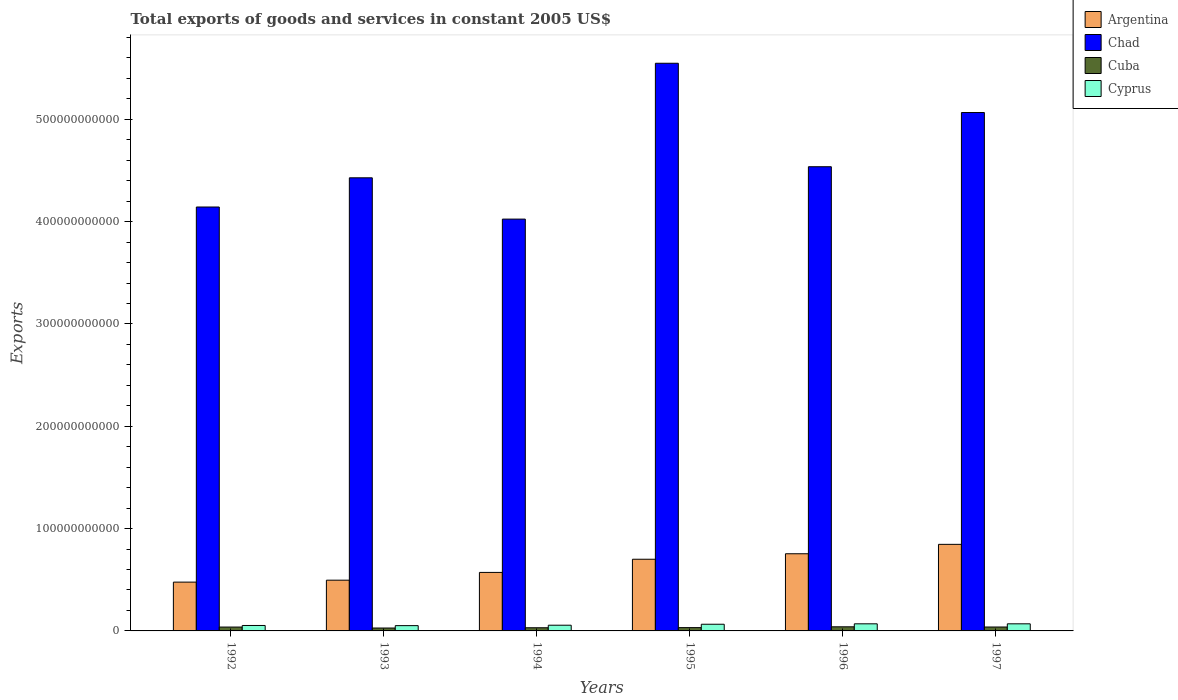How many groups of bars are there?
Provide a succinct answer. 6. Are the number of bars on each tick of the X-axis equal?
Your answer should be compact. Yes. How many bars are there on the 4th tick from the left?
Provide a succinct answer. 4. What is the label of the 4th group of bars from the left?
Offer a very short reply. 1995. What is the total exports of goods and services in Cyprus in 1992?
Provide a short and direct response. 5.31e+09. Across all years, what is the maximum total exports of goods and services in Argentina?
Provide a short and direct response. 8.46e+1. Across all years, what is the minimum total exports of goods and services in Argentina?
Provide a short and direct response. 4.77e+1. In which year was the total exports of goods and services in Chad minimum?
Offer a terse response. 1994. What is the total total exports of goods and services in Cuba in the graph?
Your answer should be compact. 2.08e+1. What is the difference between the total exports of goods and services in Argentina in 1993 and that in 1997?
Your response must be concise. -3.50e+1. What is the difference between the total exports of goods and services in Cuba in 1996 and the total exports of goods and services in Argentina in 1994?
Your answer should be compact. -5.32e+1. What is the average total exports of goods and services in Cuba per year?
Your answer should be compact. 3.46e+09. In the year 1994, what is the difference between the total exports of goods and services in Cyprus and total exports of goods and services in Argentina?
Keep it short and to the point. -5.16e+1. In how many years, is the total exports of goods and services in Cyprus greater than 40000000000 US$?
Provide a succinct answer. 0. What is the ratio of the total exports of goods and services in Chad in 1993 to that in 1996?
Offer a terse response. 0.98. Is the total exports of goods and services in Argentina in 1992 less than that in 1995?
Ensure brevity in your answer.  Yes. What is the difference between the highest and the second highest total exports of goods and services in Argentina?
Keep it short and to the point. 9.18e+09. What is the difference between the highest and the lowest total exports of goods and services in Argentina?
Offer a very short reply. 3.69e+1. In how many years, is the total exports of goods and services in Chad greater than the average total exports of goods and services in Chad taken over all years?
Keep it short and to the point. 2. Is the sum of the total exports of goods and services in Cuba in 1992 and 1993 greater than the maximum total exports of goods and services in Chad across all years?
Your answer should be very brief. No. What does the 2nd bar from the left in 1993 represents?
Ensure brevity in your answer.  Chad. What does the 1st bar from the right in 1995 represents?
Give a very brief answer. Cyprus. How many bars are there?
Your response must be concise. 24. Are all the bars in the graph horizontal?
Offer a very short reply. No. How many years are there in the graph?
Offer a terse response. 6. What is the difference between two consecutive major ticks on the Y-axis?
Offer a terse response. 1.00e+11. Does the graph contain grids?
Your response must be concise. No. Where does the legend appear in the graph?
Your answer should be compact. Top right. What is the title of the graph?
Ensure brevity in your answer.  Total exports of goods and services in constant 2005 US$. Does "Grenada" appear as one of the legend labels in the graph?
Provide a succinct answer. No. What is the label or title of the Y-axis?
Make the answer very short. Exports. What is the Exports of Argentina in 1992?
Offer a terse response. 4.77e+1. What is the Exports of Chad in 1992?
Keep it short and to the point. 4.14e+11. What is the Exports of Cuba in 1992?
Offer a terse response. 3.77e+09. What is the Exports of Cyprus in 1992?
Make the answer very short. 5.31e+09. What is the Exports of Argentina in 1993?
Your response must be concise. 4.96e+1. What is the Exports of Chad in 1993?
Make the answer very short. 4.43e+11. What is the Exports in Cuba in 1993?
Your answer should be very brief. 2.83e+09. What is the Exports of Cyprus in 1993?
Keep it short and to the point. 5.16e+09. What is the Exports of Argentina in 1994?
Give a very brief answer. 5.72e+1. What is the Exports in Chad in 1994?
Your answer should be very brief. 4.03e+11. What is the Exports of Cuba in 1994?
Give a very brief answer. 3.09e+09. What is the Exports of Cyprus in 1994?
Offer a very short reply. 5.59e+09. What is the Exports of Argentina in 1995?
Give a very brief answer. 7.01e+1. What is the Exports of Chad in 1995?
Ensure brevity in your answer.  5.55e+11. What is the Exports of Cuba in 1995?
Your answer should be compact. 3.23e+09. What is the Exports of Cyprus in 1995?
Ensure brevity in your answer.  6.53e+09. What is the Exports of Argentina in 1996?
Provide a succinct answer. 7.54e+1. What is the Exports in Chad in 1996?
Make the answer very short. 4.54e+11. What is the Exports of Cuba in 1996?
Your answer should be compact. 4.02e+09. What is the Exports in Cyprus in 1996?
Keep it short and to the point. 6.93e+09. What is the Exports in Argentina in 1997?
Your answer should be compact. 8.46e+1. What is the Exports in Chad in 1997?
Offer a terse response. 5.07e+11. What is the Exports of Cuba in 1997?
Keep it short and to the point. 3.82e+09. What is the Exports of Cyprus in 1997?
Make the answer very short. 6.94e+09. Across all years, what is the maximum Exports of Argentina?
Provide a short and direct response. 8.46e+1. Across all years, what is the maximum Exports in Chad?
Your response must be concise. 5.55e+11. Across all years, what is the maximum Exports in Cuba?
Ensure brevity in your answer.  4.02e+09. Across all years, what is the maximum Exports of Cyprus?
Give a very brief answer. 6.94e+09. Across all years, what is the minimum Exports of Argentina?
Offer a terse response. 4.77e+1. Across all years, what is the minimum Exports in Chad?
Make the answer very short. 4.03e+11. Across all years, what is the minimum Exports of Cuba?
Ensure brevity in your answer.  2.83e+09. Across all years, what is the minimum Exports in Cyprus?
Provide a succinct answer. 5.16e+09. What is the total Exports of Argentina in the graph?
Offer a very short reply. 3.85e+11. What is the total Exports in Chad in the graph?
Your answer should be very brief. 2.77e+12. What is the total Exports in Cuba in the graph?
Your response must be concise. 2.08e+1. What is the total Exports of Cyprus in the graph?
Your answer should be compact. 3.65e+1. What is the difference between the Exports of Argentina in 1992 and that in 1993?
Offer a terse response. -1.90e+09. What is the difference between the Exports in Chad in 1992 and that in 1993?
Your answer should be compact. -2.85e+1. What is the difference between the Exports in Cuba in 1992 and that in 1993?
Provide a succinct answer. 9.41e+08. What is the difference between the Exports in Cyprus in 1992 and that in 1993?
Make the answer very short. 1.51e+08. What is the difference between the Exports in Argentina in 1992 and that in 1994?
Provide a succinct answer. -9.49e+09. What is the difference between the Exports of Chad in 1992 and that in 1994?
Offer a terse response. 1.18e+1. What is the difference between the Exports of Cuba in 1992 and that in 1994?
Offer a terse response. 6.82e+08. What is the difference between the Exports of Cyprus in 1992 and that in 1994?
Your answer should be very brief. -2.72e+08. What is the difference between the Exports of Argentina in 1992 and that in 1995?
Ensure brevity in your answer.  -2.24e+1. What is the difference between the Exports in Chad in 1992 and that in 1995?
Ensure brevity in your answer.  -1.41e+11. What is the difference between the Exports in Cuba in 1992 and that in 1995?
Give a very brief answer. 5.48e+08. What is the difference between the Exports in Cyprus in 1992 and that in 1995?
Ensure brevity in your answer.  -1.21e+09. What is the difference between the Exports of Argentina in 1992 and that in 1996?
Ensure brevity in your answer.  -2.77e+1. What is the difference between the Exports of Chad in 1992 and that in 1996?
Make the answer very short. -3.94e+1. What is the difference between the Exports in Cuba in 1992 and that in 1996?
Offer a terse response. -2.46e+08. What is the difference between the Exports of Cyprus in 1992 and that in 1996?
Your answer should be very brief. -1.62e+09. What is the difference between the Exports of Argentina in 1992 and that in 1997?
Your response must be concise. -3.69e+1. What is the difference between the Exports of Chad in 1992 and that in 1997?
Make the answer very short. -9.24e+1. What is the difference between the Exports in Cuba in 1992 and that in 1997?
Provide a short and direct response. -4.83e+07. What is the difference between the Exports in Cyprus in 1992 and that in 1997?
Give a very brief answer. -1.62e+09. What is the difference between the Exports of Argentina in 1993 and that in 1994?
Your answer should be compact. -7.59e+09. What is the difference between the Exports of Chad in 1993 and that in 1994?
Keep it short and to the point. 4.04e+1. What is the difference between the Exports of Cuba in 1993 and that in 1994?
Your response must be concise. -2.58e+08. What is the difference between the Exports in Cyprus in 1993 and that in 1994?
Offer a very short reply. -4.23e+08. What is the difference between the Exports in Argentina in 1993 and that in 1995?
Your answer should be very brief. -2.05e+1. What is the difference between the Exports of Chad in 1993 and that in 1995?
Give a very brief answer. -1.12e+11. What is the difference between the Exports in Cuba in 1993 and that in 1995?
Provide a succinct answer. -3.92e+08. What is the difference between the Exports in Cyprus in 1993 and that in 1995?
Ensure brevity in your answer.  -1.36e+09. What is the difference between the Exports of Argentina in 1993 and that in 1996?
Keep it short and to the point. -2.58e+1. What is the difference between the Exports in Chad in 1993 and that in 1996?
Offer a terse response. -1.08e+1. What is the difference between the Exports of Cuba in 1993 and that in 1996?
Give a very brief answer. -1.19e+09. What is the difference between the Exports of Cyprus in 1993 and that in 1996?
Your response must be concise. -1.77e+09. What is the difference between the Exports in Argentina in 1993 and that in 1997?
Offer a very short reply. -3.50e+1. What is the difference between the Exports of Chad in 1993 and that in 1997?
Ensure brevity in your answer.  -6.38e+1. What is the difference between the Exports of Cuba in 1993 and that in 1997?
Your answer should be compact. -9.89e+08. What is the difference between the Exports in Cyprus in 1993 and that in 1997?
Offer a terse response. -1.77e+09. What is the difference between the Exports in Argentina in 1994 and that in 1995?
Your response must be concise. -1.29e+1. What is the difference between the Exports of Chad in 1994 and that in 1995?
Your answer should be compact. -1.52e+11. What is the difference between the Exports of Cuba in 1994 and that in 1995?
Provide a short and direct response. -1.34e+08. What is the difference between the Exports of Cyprus in 1994 and that in 1995?
Offer a very short reply. -9.41e+08. What is the difference between the Exports in Argentina in 1994 and that in 1996?
Offer a very short reply. -1.82e+1. What is the difference between the Exports in Chad in 1994 and that in 1996?
Provide a succinct answer. -5.12e+1. What is the difference between the Exports in Cuba in 1994 and that in 1996?
Provide a succinct answer. -9.28e+08. What is the difference between the Exports of Cyprus in 1994 and that in 1996?
Your answer should be compact. -1.35e+09. What is the difference between the Exports in Argentina in 1994 and that in 1997?
Your answer should be very brief. -2.74e+1. What is the difference between the Exports in Chad in 1994 and that in 1997?
Make the answer very short. -1.04e+11. What is the difference between the Exports in Cuba in 1994 and that in 1997?
Provide a short and direct response. -7.31e+08. What is the difference between the Exports of Cyprus in 1994 and that in 1997?
Offer a very short reply. -1.35e+09. What is the difference between the Exports in Argentina in 1995 and that in 1996?
Offer a very short reply. -5.36e+09. What is the difference between the Exports in Chad in 1995 and that in 1996?
Your answer should be compact. 1.01e+11. What is the difference between the Exports of Cuba in 1995 and that in 1996?
Provide a short and direct response. -7.94e+08. What is the difference between the Exports of Cyprus in 1995 and that in 1996?
Offer a very short reply. -4.08e+08. What is the difference between the Exports of Argentina in 1995 and that in 1997?
Give a very brief answer. -1.45e+1. What is the difference between the Exports of Chad in 1995 and that in 1997?
Provide a succinct answer. 4.81e+1. What is the difference between the Exports in Cuba in 1995 and that in 1997?
Your answer should be compact. -5.97e+08. What is the difference between the Exports of Cyprus in 1995 and that in 1997?
Give a very brief answer. -4.11e+08. What is the difference between the Exports in Argentina in 1996 and that in 1997?
Your answer should be compact. -9.18e+09. What is the difference between the Exports of Chad in 1996 and that in 1997?
Offer a terse response. -5.30e+1. What is the difference between the Exports of Cuba in 1996 and that in 1997?
Provide a succinct answer. 1.97e+08. What is the difference between the Exports in Cyprus in 1996 and that in 1997?
Provide a short and direct response. -3.51e+06. What is the difference between the Exports of Argentina in 1992 and the Exports of Chad in 1993?
Your answer should be very brief. -3.95e+11. What is the difference between the Exports in Argentina in 1992 and the Exports in Cuba in 1993?
Your response must be concise. 4.49e+1. What is the difference between the Exports of Argentina in 1992 and the Exports of Cyprus in 1993?
Your answer should be very brief. 4.25e+1. What is the difference between the Exports in Chad in 1992 and the Exports in Cuba in 1993?
Make the answer very short. 4.11e+11. What is the difference between the Exports in Chad in 1992 and the Exports in Cyprus in 1993?
Make the answer very short. 4.09e+11. What is the difference between the Exports of Cuba in 1992 and the Exports of Cyprus in 1993?
Keep it short and to the point. -1.39e+09. What is the difference between the Exports in Argentina in 1992 and the Exports in Chad in 1994?
Ensure brevity in your answer.  -3.55e+11. What is the difference between the Exports of Argentina in 1992 and the Exports of Cuba in 1994?
Ensure brevity in your answer.  4.46e+1. What is the difference between the Exports of Argentina in 1992 and the Exports of Cyprus in 1994?
Make the answer very short. 4.21e+1. What is the difference between the Exports in Chad in 1992 and the Exports in Cuba in 1994?
Offer a terse response. 4.11e+11. What is the difference between the Exports of Chad in 1992 and the Exports of Cyprus in 1994?
Your answer should be compact. 4.09e+11. What is the difference between the Exports in Cuba in 1992 and the Exports in Cyprus in 1994?
Provide a short and direct response. -1.81e+09. What is the difference between the Exports of Argentina in 1992 and the Exports of Chad in 1995?
Provide a short and direct response. -5.07e+11. What is the difference between the Exports in Argentina in 1992 and the Exports in Cuba in 1995?
Provide a short and direct response. 4.45e+1. What is the difference between the Exports in Argentina in 1992 and the Exports in Cyprus in 1995?
Make the answer very short. 4.12e+1. What is the difference between the Exports of Chad in 1992 and the Exports of Cuba in 1995?
Provide a short and direct response. 4.11e+11. What is the difference between the Exports in Chad in 1992 and the Exports in Cyprus in 1995?
Your answer should be very brief. 4.08e+11. What is the difference between the Exports of Cuba in 1992 and the Exports of Cyprus in 1995?
Keep it short and to the point. -2.75e+09. What is the difference between the Exports of Argentina in 1992 and the Exports of Chad in 1996?
Offer a very short reply. -4.06e+11. What is the difference between the Exports of Argentina in 1992 and the Exports of Cuba in 1996?
Give a very brief answer. 4.37e+1. What is the difference between the Exports in Argentina in 1992 and the Exports in Cyprus in 1996?
Your response must be concise. 4.08e+1. What is the difference between the Exports of Chad in 1992 and the Exports of Cuba in 1996?
Provide a succinct answer. 4.10e+11. What is the difference between the Exports in Chad in 1992 and the Exports in Cyprus in 1996?
Provide a short and direct response. 4.07e+11. What is the difference between the Exports in Cuba in 1992 and the Exports in Cyprus in 1996?
Provide a short and direct response. -3.16e+09. What is the difference between the Exports of Argentina in 1992 and the Exports of Chad in 1997?
Give a very brief answer. -4.59e+11. What is the difference between the Exports in Argentina in 1992 and the Exports in Cuba in 1997?
Ensure brevity in your answer.  4.39e+1. What is the difference between the Exports in Argentina in 1992 and the Exports in Cyprus in 1997?
Provide a short and direct response. 4.08e+1. What is the difference between the Exports in Chad in 1992 and the Exports in Cuba in 1997?
Give a very brief answer. 4.10e+11. What is the difference between the Exports of Chad in 1992 and the Exports of Cyprus in 1997?
Offer a terse response. 4.07e+11. What is the difference between the Exports of Cuba in 1992 and the Exports of Cyprus in 1997?
Offer a terse response. -3.16e+09. What is the difference between the Exports of Argentina in 1993 and the Exports of Chad in 1994?
Your answer should be very brief. -3.53e+11. What is the difference between the Exports of Argentina in 1993 and the Exports of Cuba in 1994?
Your answer should be very brief. 4.65e+1. What is the difference between the Exports of Argentina in 1993 and the Exports of Cyprus in 1994?
Provide a short and direct response. 4.40e+1. What is the difference between the Exports in Chad in 1993 and the Exports in Cuba in 1994?
Offer a very short reply. 4.40e+11. What is the difference between the Exports of Chad in 1993 and the Exports of Cyprus in 1994?
Ensure brevity in your answer.  4.37e+11. What is the difference between the Exports of Cuba in 1993 and the Exports of Cyprus in 1994?
Offer a terse response. -2.75e+09. What is the difference between the Exports in Argentina in 1993 and the Exports in Chad in 1995?
Your answer should be compact. -5.05e+11. What is the difference between the Exports of Argentina in 1993 and the Exports of Cuba in 1995?
Give a very brief answer. 4.64e+1. What is the difference between the Exports in Argentina in 1993 and the Exports in Cyprus in 1995?
Your answer should be very brief. 4.31e+1. What is the difference between the Exports of Chad in 1993 and the Exports of Cuba in 1995?
Ensure brevity in your answer.  4.40e+11. What is the difference between the Exports of Chad in 1993 and the Exports of Cyprus in 1995?
Give a very brief answer. 4.36e+11. What is the difference between the Exports of Cuba in 1993 and the Exports of Cyprus in 1995?
Your answer should be very brief. -3.69e+09. What is the difference between the Exports of Argentina in 1993 and the Exports of Chad in 1996?
Your answer should be compact. -4.04e+11. What is the difference between the Exports of Argentina in 1993 and the Exports of Cuba in 1996?
Give a very brief answer. 4.56e+1. What is the difference between the Exports in Argentina in 1993 and the Exports in Cyprus in 1996?
Give a very brief answer. 4.27e+1. What is the difference between the Exports in Chad in 1993 and the Exports in Cuba in 1996?
Your answer should be very brief. 4.39e+11. What is the difference between the Exports of Chad in 1993 and the Exports of Cyprus in 1996?
Your response must be concise. 4.36e+11. What is the difference between the Exports of Cuba in 1993 and the Exports of Cyprus in 1996?
Provide a short and direct response. -4.10e+09. What is the difference between the Exports of Argentina in 1993 and the Exports of Chad in 1997?
Provide a succinct answer. -4.57e+11. What is the difference between the Exports of Argentina in 1993 and the Exports of Cuba in 1997?
Provide a succinct answer. 4.58e+1. What is the difference between the Exports of Argentina in 1993 and the Exports of Cyprus in 1997?
Offer a very short reply. 4.27e+1. What is the difference between the Exports in Chad in 1993 and the Exports in Cuba in 1997?
Offer a very short reply. 4.39e+11. What is the difference between the Exports in Chad in 1993 and the Exports in Cyprus in 1997?
Your response must be concise. 4.36e+11. What is the difference between the Exports in Cuba in 1993 and the Exports in Cyprus in 1997?
Provide a succinct answer. -4.10e+09. What is the difference between the Exports in Argentina in 1994 and the Exports in Chad in 1995?
Your answer should be compact. -4.98e+11. What is the difference between the Exports of Argentina in 1994 and the Exports of Cuba in 1995?
Offer a very short reply. 5.40e+1. What is the difference between the Exports of Argentina in 1994 and the Exports of Cyprus in 1995?
Provide a succinct answer. 5.07e+1. What is the difference between the Exports in Chad in 1994 and the Exports in Cuba in 1995?
Keep it short and to the point. 3.99e+11. What is the difference between the Exports in Chad in 1994 and the Exports in Cyprus in 1995?
Offer a very short reply. 3.96e+11. What is the difference between the Exports in Cuba in 1994 and the Exports in Cyprus in 1995?
Make the answer very short. -3.43e+09. What is the difference between the Exports of Argentina in 1994 and the Exports of Chad in 1996?
Keep it short and to the point. -3.97e+11. What is the difference between the Exports of Argentina in 1994 and the Exports of Cuba in 1996?
Give a very brief answer. 5.32e+1. What is the difference between the Exports in Argentina in 1994 and the Exports in Cyprus in 1996?
Ensure brevity in your answer.  5.02e+1. What is the difference between the Exports of Chad in 1994 and the Exports of Cuba in 1996?
Your answer should be very brief. 3.98e+11. What is the difference between the Exports in Chad in 1994 and the Exports in Cyprus in 1996?
Your answer should be very brief. 3.96e+11. What is the difference between the Exports of Cuba in 1994 and the Exports of Cyprus in 1996?
Offer a very short reply. -3.84e+09. What is the difference between the Exports in Argentina in 1994 and the Exports in Chad in 1997?
Your answer should be compact. -4.49e+11. What is the difference between the Exports in Argentina in 1994 and the Exports in Cuba in 1997?
Give a very brief answer. 5.34e+1. What is the difference between the Exports of Argentina in 1994 and the Exports of Cyprus in 1997?
Give a very brief answer. 5.02e+1. What is the difference between the Exports in Chad in 1994 and the Exports in Cuba in 1997?
Provide a short and direct response. 3.99e+11. What is the difference between the Exports of Chad in 1994 and the Exports of Cyprus in 1997?
Provide a succinct answer. 3.96e+11. What is the difference between the Exports in Cuba in 1994 and the Exports in Cyprus in 1997?
Provide a short and direct response. -3.85e+09. What is the difference between the Exports in Argentina in 1995 and the Exports in Chad in 1996?
Your answer should be very brief. -3.84e+11. What is the difference between the Exports of Argentina in 1995 and the Exports of Cuba in 1996?
Your response must be concise. 6.60e+1. What is the difference between the Exports of Argentina in 1995 and the Exports of Cyprus in 1996?
Give a very brief answer. 6.31e+1. What is the difference between the Exports of Chad in 1995 and the Exports of Cuba in 1996?
Ensure brevity in your answer.  5.51e+11. What is the difference between the Exports in Chad in 1995 and the Exports in Cyprus in 1996?
Provide a succinct answer. 5.48e+11. What is the difference between the Exports of Cuba in 1995 and the Exports of Cyprus in 1996?
Provide a succinct answer. -3.71e+09. What is the difference between the Exports in Argentina in 1995 and the Exports in Chad in 1997?
Your answer should be very brief. -4.37e+11. What is the difference between the Exports of Argentina in 1995 and the Exports of Cuba in 1997?
Offer a very short reply. 6.62e+1. What is the difference between the Exports of Argentina in 1995 and the Exports of Cyprus in 1997?
Offer a terse response. 6.31e+1. What is the difference between the Exports in Chad in 1995 and the Exports in Cuba in 1997?
Offer a very short reply. 5.51e+11. What is the difference between the Exports of Chad in 1995 and the Exports of Cyprus in 1997?
Your answer should be very brief. 5.48e+11. What is the difference between the Exports of Cuba in 1995 and the Exports of Cyprus in 1997?
Offer a very short reply. -3.71e+09. What is the difference between the Exports in Argentina in 1996 and the Exports in Chad in 1997?
Ensure brevity in your answer.  -4.31e+11. What is the difference between the Exports of Argentina in 1996 and the Exports of Cuba in 1997?
Make the answer very short. 7.16e+1. What is the difference between the Exports in Argentina in 1996 and the Exports in Cyprus in 1997?
Your response must be concise. 6.85e+1. What is the difference between the Exports of Chad in 1996 and the Exports of Cuba in 1997?
Your response must be concise. 4.50e+11. What is the difference between the Exports of Chad in 1996 and the Exports of Cyprus in 1997?
Provide a succinct answer. 4.47e+11. What is the difference between the Exports in Cuba in 1996 and the Exports in Cyprus in 1997?
Offer a terse response. -2.92e+09. What is the average Exports in Argentina per year?
Offer a very short reply. 6.41e+1. What is the average Exports in Chad per year?
Keep it short and to the point. 4.62e+11. What is the average Exports in Cuba per year?
Provide a succinct answer. 3.46e+09. What is the average Exports in Cyprus per year?
Provide a short and direct response. 6.08e+09. In the year 1992, what is the difference between the Exports of Argentina and Exports of Chad?
Provide a short and direct response. -3.67e+11. In the year 1992, what is the difference between the Exports in Argentina and Exports in Cuba?
Your answer should be compact. 4.39e+1. In the year 1992, what is the difference between the Exports in Argentina and Exports in Cyprus?
Offer a very short reply. 4.24e+1. In the year 1992, what is the difference between the Exports in Chad and Exports in Cuba?
Provide a short and direct response. 4.11e+11. In the year 1992, what is the difference between the Exports of Chad and Exports of Cyprus?
Keep it short and to the point. 4.09e+11. In the year 1992, what is the difference between the Exports in Cuba and Exports in Cyprus?
Ensure brevity in your answer.  -1.54e+09. In the year 1993, what is the difference between the Exports in Argentina and Exports in Chad?
Your response must be concise. -3.93e+11. In the year 1993, what is the difference between the Exports of Argentina and Exports of Cuba?
Make the answer very short. 4.68e+1. In the year 1993, what is the difference between the Exports in Argentina and Exports in Cyprus?
Offer a very short reply. 4.44e+1. In the year 1993, what is the difference between the Exports in Chad and Exports in Cuba?
Your response must be concise. 4.40e+11. In the year 1993, what is the difference between the Exports in Chad and Exports in Cyprus?
Offer a terse response. 4.38e+11. In the year 1993, what is the difference between the Exports in Cuba and Exports in Cyprus?
Offer a very short reply. -2.33e+09. In the year 1994, what is the difference between the Exports in Argentina and Exports in Chad?
Offer a very short reply. -3.45e+11. In the year 1994, what is the difference between the Exports in Argentina and Exports in Cuba?
Provide a short and direct response. 5.41e+1. In the year 1994, what is the difference between the Exports in Argentina and Exports in Cyprus?
Offer a terse response. 5.16e+1. In the year 1994, what is the difference between the Exports in Chad and Exports in Cuba?
Keep it short and to the point. 3.99e+11. In the year 1994, what is the difference between the Exports in Chad and Exports in Cyprus?
Provide a short and direct response. 3.97e+11. In the year 1994, what is the difference between the Exports of Cuba and Exports of Cyprus?
Give a very brief answer. -2.49e+09. In the year 1995, what is the difference between the Exports of Argentina and Exports of Chad?
Offer a terse response. -4.85e+11. In the year 1995, what is the difference between the Exports of Argentina and Exports of Cuba?
Your answer should be very brief. 6.68e+1. In the year 1995, what is the difference between the Exports of Argentina and Exports of Cyprus?
Give a very brief answer. 6.35e+1. In the year 1995, what is the difference between the Exports in Chad and Exports in Cuba?
Your answer should be compact. 5.52e+11. In the year 1995, what is the difference between the Exports of Chad and Exports of Cyprus?
Offer a very short reply. 5.48e+11. In the year 1995, what is the difference between the Exports in Cuba and Exports in Cyprus?
Make the answer very short. -3.30e+09. In the year 1996, what is the difference between the Exports in Argentina and Exports in Chad?
Give a very brief answer. -3.78e+11. In the year 1996, what is the difference between the Exports in Argentina and Exports in Cuba?
Provide a short and direct response. 7.14e+1. In the year 1996, what is the difference between the Exports in Argentina and Exports in Cyprus?
Your response must be concise. 6.85e+1. In the year 1996, what is the difference between the Exports of Chad and Exports of Cuba?
Your answer should be compact. 4.50e+11. In the year 1996, what is the difference between the Exports of Chad and Exports of Cyprus?
Offer a very short reply. 4.47e+11. In the year 1996, what is the difference between the Exports in Cuba and Exports in Cyprus?
Your answer should be compact. -2.91e+09. In the year 1997, what is the difference between the Exports in Argentina and Exports in Chad?
Your answer should be compact. -4.22e+11. In the year 1997, what is the difference between the Exports in Argentina and Exports in Cuba?
Keep it short and to the point. 8.08e+1. In the year 1997, what is the difference between the Exports of Argentina and Exports of Cyprus?
Your answer should be very brief. 7.77e+1. In the year 1997, what is the difference between the Exports in Chad and Exports in Cuba?
Your answer should be very brief. 5.03e+11. In the year 1997, what is the difference between the Exports of Chad and Exports of Cyprus?
Provide a short and direct response. 5.00e+11. In the year 1997, what is the difference between the Exports of Cuba and Exports of Cyprus?
Provide a succinct answer. -3.12e+09. What is the ratio of the Exports of Argentina in 1992 to that in 1993?
Offer a very short reply. 0.96. What is the ratio of the Exports in Chad in 1992 to that in 1993?
Offer a very short reply. 0.94. What is the ratio of the Exports of Cuba in 1992 to that in 1993?
Your response must be concise. 1.33. What is the ratio of the Exports of Cyprus in 1992 to that in 1993?
Give a very brief answer. 1.03. What is the ratio of the Exports in Argentina in 1992 to that in 1994?
Offer a very short reply. 0.83. What is the ratio of the Exports in Chad in 1992 to that in 1994?
Provide a short and direct response. 1.03. What is the ratio of the Exports of Cuba in 1992 to that in 1994?
Give a very brief answer. 1.22. What is the ratio of the Exports in Cyprus in 1992 to that in 1994?
Ensure brevity in your answer.  0.95. What is the ratio of the Exports of Argentina in 1992 to that in 1995?
Give a very brief answer. 0.68. What is the ratio of the Exports in Chad in 1992 to that in 1995?
Make the answer very short. 0.75. What is the ratio of the Exports in Cuba in 1992 to that in 1995?
Keep it short and to the point. 1.17. What is the ratio of the Exports in Cyprus in 1992 to that in 1995?
Give a very brief answer. 0.81. What is the ratio of the Exports in Argentina in 1992 to that in 1996?
Offer a very short reply. 0.63. What is the ratio of the Exports in Chad in 1992 to that in 1996?
Your response must be concise. 0.91. What is the ratio of the Exports in Cuba in 1992 to that in 1996?
Ensure brevity in your answer.  0.94. What is the ratio of the Exports in Cyprus in 1992 to that in 1996?
Offer a terse response. 0.77. What is the ratio of the Exports in Argentina in 1992 to that in 1997?
Keep it short and to the point. 0.56. What is the ratio of the Exports of Chad in 1992 to that in 1997?
Provide a succinct answer. 0.82. What is the ratio of the Exports of Cuba in 1992 to that in 1997?
Your response must be concise. 0.99. What is the ratio of the Exports of Cyprus in 1992 to that in 1997?
Your answer should be very brief. 0.77. What is the ratio of the Exports of Argentina in 1993 to that in 1994?
Your answer should be very brief. 0.87. What is the ratio of the Exports of Chad in 1993 to that in 1994?
Make the answer very short. 1.1. What is the ratio of the Exports of Cuba in 1993 to that in 1994?
Provide a succinct answer. 0.92. What is the ratio of the Exports of Cyprus in 1993 to that in 1994?
Offer a terse response. 0.92. What is the ratio of the Exports of Argentina in 1993 to that in 1995?
Ensure brevity in your answer.  0.71. What is the ratio of the Exports of Chad in 1993 to that in 1995?
Provide a short and direct response. 0.8. What is the ratio of the Exports in Cuba in 1993 to that in 1995?
Your answer should be very brief. 0.88. What is the ratio of the Exports of Cyprus in 1993 to that in 1995?
Offer a terse response. 0.79. What is the ratio of the Exports of Argentina in 1993 to that in 1996?
Provide a succinct answer. 0.66. What is the ratio of the Exports of Chad in 1993 to that in 1996?
Offer a terse response. 0.98. What is the ratio of the Exports in Cuba in 1993 to that in 1996?
Your answer should be compact. 0.7. What is the ratio of the Exports in Cyprus in 1993 to that in 1996?
Your answer should be very brief. 0.74. What is the ratio of the Exports in Argentina in 1993 to that in 1997?
Your response must be concise. 0.59. What is the ratio of the Exports of Chad in 1993 to that in 1997?
Provide a succinct answer. 0.87. What is the ratio of the Exports of Cuba in 1993 to that in 1997?
Your answer should be very brief. 0.74. What is the ratio of the Exports in Cyprus in 1993 to that in 1997?
Keep it short and to the point. 0.74. What is the ratio of the Exports in Argentina in 1994 to that in 1995?
Make the answer very short. 0.82. What is the ratio of the Exports of Chad in 1994 to that in 1995?
Your response must be concise. 0.73. What is the ratio of the Exports in Cuba in 1994 to that in 1995?
Your answer should be very brief. 0.96. What is the ratio of the Exports of Cyprus in 1994 to that in 1995?
Make the answer very short. 0.86. What is the ratio of the Exports of Argentina in 1994 to that in 1996?
Provide a short and direct response. 0.76. What is the ratio of the Exports in Chad in 1994 to that in 1996?
Your response must be concise. 0.89. What is the ratio of the Exports of Cuba in 1994 to that in 1996?
Your answer should be compact. 0.77. What is the ratio of the Exports in Cyprus in 1994 to that in 1996?
Your response must be concise. 0.81. What is the ratio of the Exports of Argentina in 1994 to that in 1997?
Keep it short and to the point. 0.68. What is the ratio of the Exports in Chad in 1994 to that in 1997?
Your response must be concise. 0.79. What is the ratio of the Exports in Cuba in 1994 to that in 1997?
Offer a very short reply. 0.81. What is the ratio of the Exports in Cyprus in 1994 to that in 1997?
Keep it short and to the point. 0.81. What is the ratio of the Exports in Argentina in 1995 to that in 1996?
Keep it short and to the point. 0.93. What is the ratio of the Exports of Chad in 1995 to that in 1996?
Ensure brevity in your answer.  1.22. What is the ratio of the Exports of Cuba in 1995 to that in 1996?
Make the answer very short. 0.8. What is the ratio of the Exports of Cyprus in 1995 to that in 1996?
Ensure brevity in your answer.  0.94. What is the ratio of the Exports of Argentina in 1995 to that in 1997?
Your response must be concise. 0.83. What is the ratio of the Exports in Chad in 1995 to that in 1997?
Your response must be concise. 1.09. What is the ratio of the Exports of Cuba in 1995 to that in 1997?
Your answer should be very brief. 0.84. What is the ratio of the Exports of Cyprus in 1995 to that in 1997?
Give a very brief answer. 0.94. What is the ratio of the Exports in Argentina in 1996 to that in 1997?
Keep it short and to the point. 0.89. What is the ratio of the Exports of Chad in 1996 to that in 1997?
Provide a short and direct response. 0.9. What is the ratio of the Exports of Cuba in 1996 to that in 1997?
Your response must be concise. 1.05. What is the difference between the highest and the second highest Exports in Argentina?
Offer a terse response. 9.18e+09. What is the difference between the highest and the second highest Exports in Chad?
Give a very brief answer. 4.81e+1. What is the difference between the highest and the second highest Exports in Cuba?
Offer a very short reply. 1.97e+08. What is the difference between the highest and the second highest Exports of Cyprus?
Provide a short and direct response. 3.51e+06. What is the difference between the highest and the lowest Exports of Argentina?
Provide a short and direct response. 3.69e+1. What is the difference between the highest and the lowest Exports in Chad?
Your answer should be very brief. 1.52e+11. What is the difference between the highest and the lowest Exports in Cuba?
Provide a succinct answer. 1.19e+09. What is the difference between the highest and the lowest Exports of Cyprus?
Keep it short and to the point. 1.77e+09. 